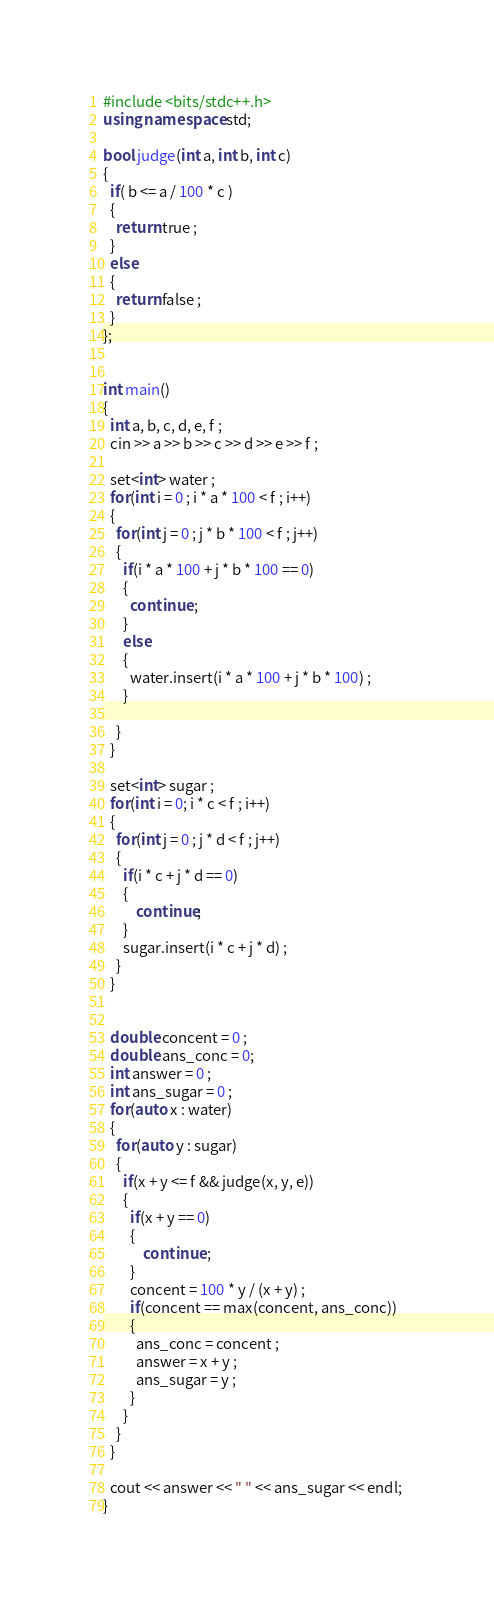<code> <loc_0><loc_0><loc_500><loc_500><_C++_>#include <bits/stdc++.h>
using namespace std;

bool judge(int a, int b, int c)
{
  if( b <= a / 100 * c )
  {
    return true ;
  }
  else
  {
    return false ;
  }
};


int main()
{
  int a, b, c, d, e, f ;
  cin >> a >> b >> c >> d >> e >> f ;

  set<int> water ;
  for(int i = 0 ; i * a * 100 < f ; i++)
  {
    for(int j = 0 ; j * b * 100 < f ; j++)
    {
      if(i * a * 100 + j * b * 100 == 0)
      {
        continue ;
      }
      else
      {
        water.insert(i * a * 100 + j * b * 100) ;
      }
        
    }
  }

  set<int> sugar ;
  for(int i = 0; i * c < f ; i++)
  {
    for(int j = 0 ; j * d < f ; j++)
    {
      if(i * c + j * d == 0)
      {
          continue;
      }
      sugar.insert(i * c + j * d) ;
    }
  }


  double concent = 0 ;
  double ans_conc = 0;
  int answer = 0 ;
  int ans_sugar = 0 ;
  for(auto x : water)
  {
    for(auto y : sugar)
    {
      if(x + y <= f && judge(x, y, e))
      {
        if(x + y == 0)
        {
            continue ;
        }
        concent = 100 * y / (x + y) ;
        if(concent == max(concent, ans_conc))
        {
          ans_conc = concent ;
          answer = x + y ;
          ans_sugar = y ;
        }
      }
    }
  }

  cout << answer << " " << ans_sugar << endl; 
}
</code> 